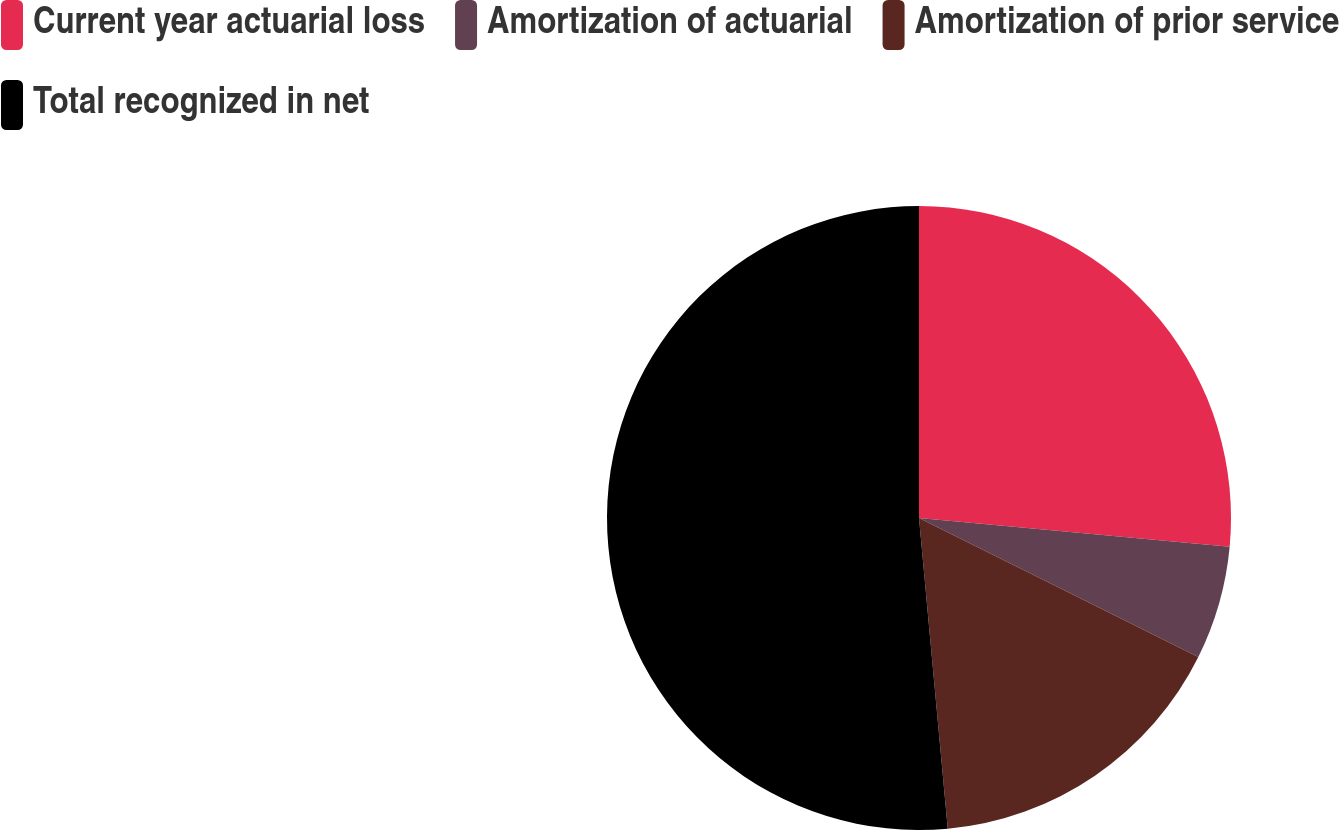Convert chart. <chart><loc_0><loc_0><loc_500><loc_500><pie_chart><fcel>Current year actuarial loss<fcel>Amortization of actuarial<fcel>Amortization of prior service<fcel>Total recognized in net<nl><fcel>26.47%<fcel>5.88%<fcel>16.18%<fcel>51.47%<nl></chart> 